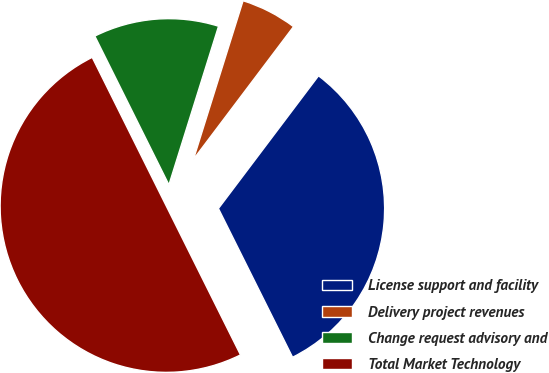<chart> <loc_0><loc_0><loc_500><loc_500><pie_chart><fcel>License support and facility<fcel>Delivery project revenues<fcel>Change request advisory and<fcel>Total Market Technology<nl><fcel>32.35%<fcel>5.46%<fcel>12.18%<fcel>50.0%<nl></chart> 